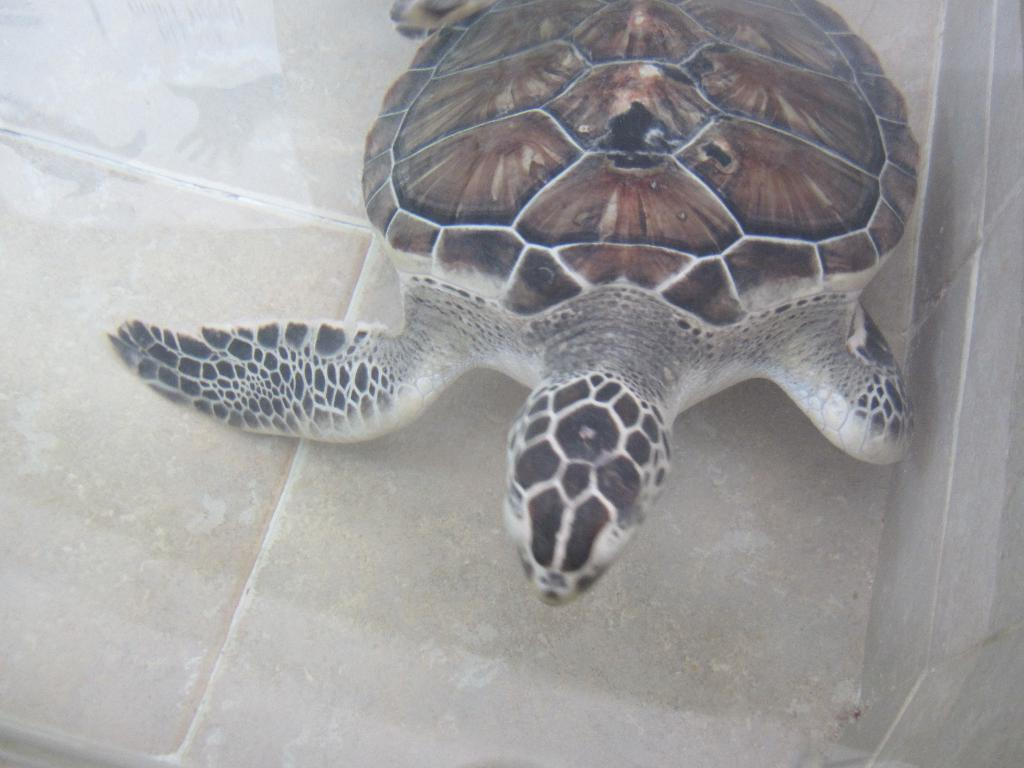What animal is present in the image? There is a turtle in the image. Where is the turtle located? The turtle is on the floor. What can be seen in the background of the image? There is a wall visible in the image. What type of kettle is being used by the turtle in the image? There is no kettle present in the image; it features a turtle on the floor with a visible wall in the background. 